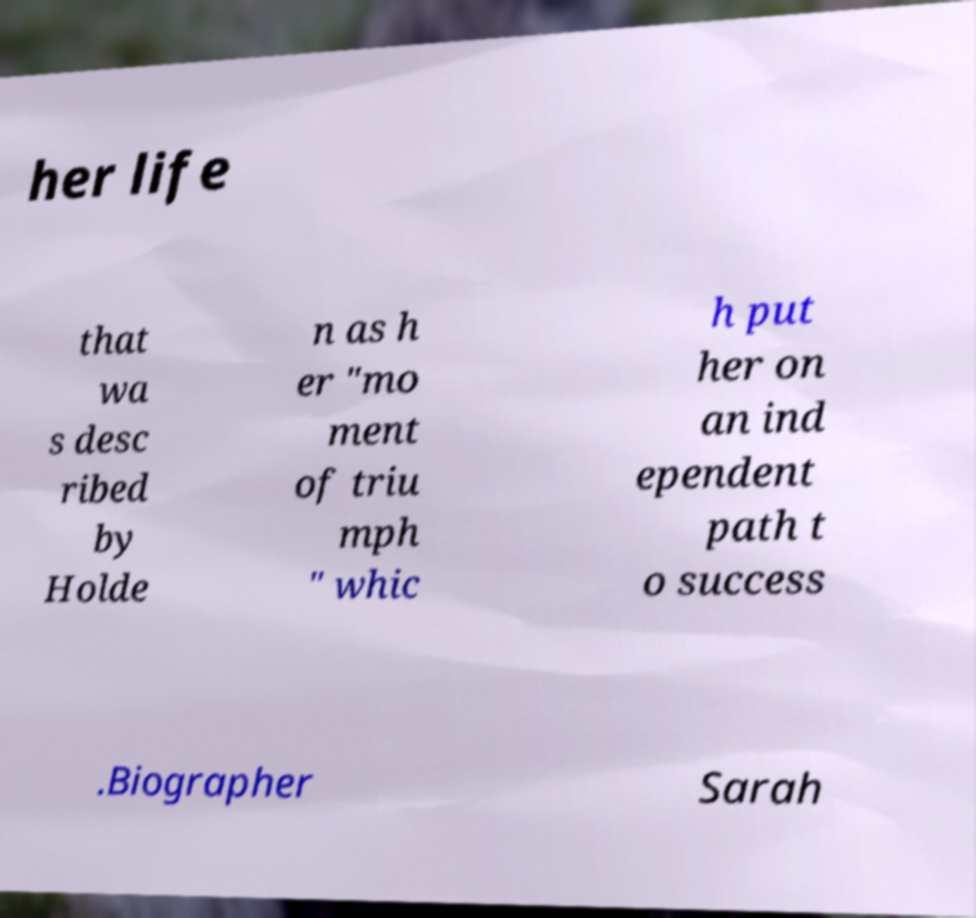Can you read and provide the text displayed in the image?This photo seems to have some interesting text. Can you extract and type it out for me? her life that wa s desc ribed by Holde n as h er "mo ment of triu mph " whic h put her on an ind ependent path t o success .Biographer Sarah 